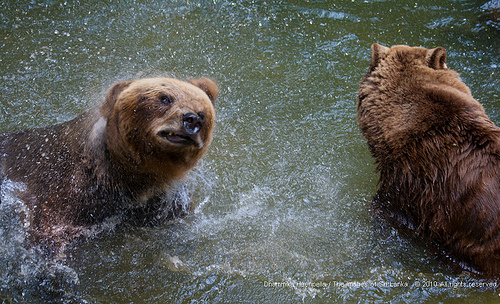<image>
Can you confirm if the bear is next to the water? No. The bear is not positioned next to the water. They are located in different areas of the scene. 